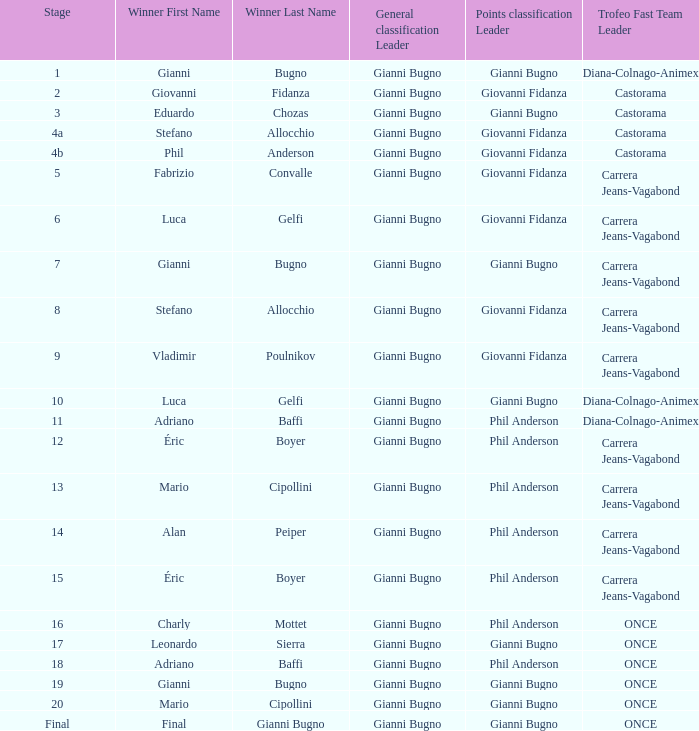In stage 10 of the trofeo event, which team emerged as the fastest? Diana-Colnago-Animex. 